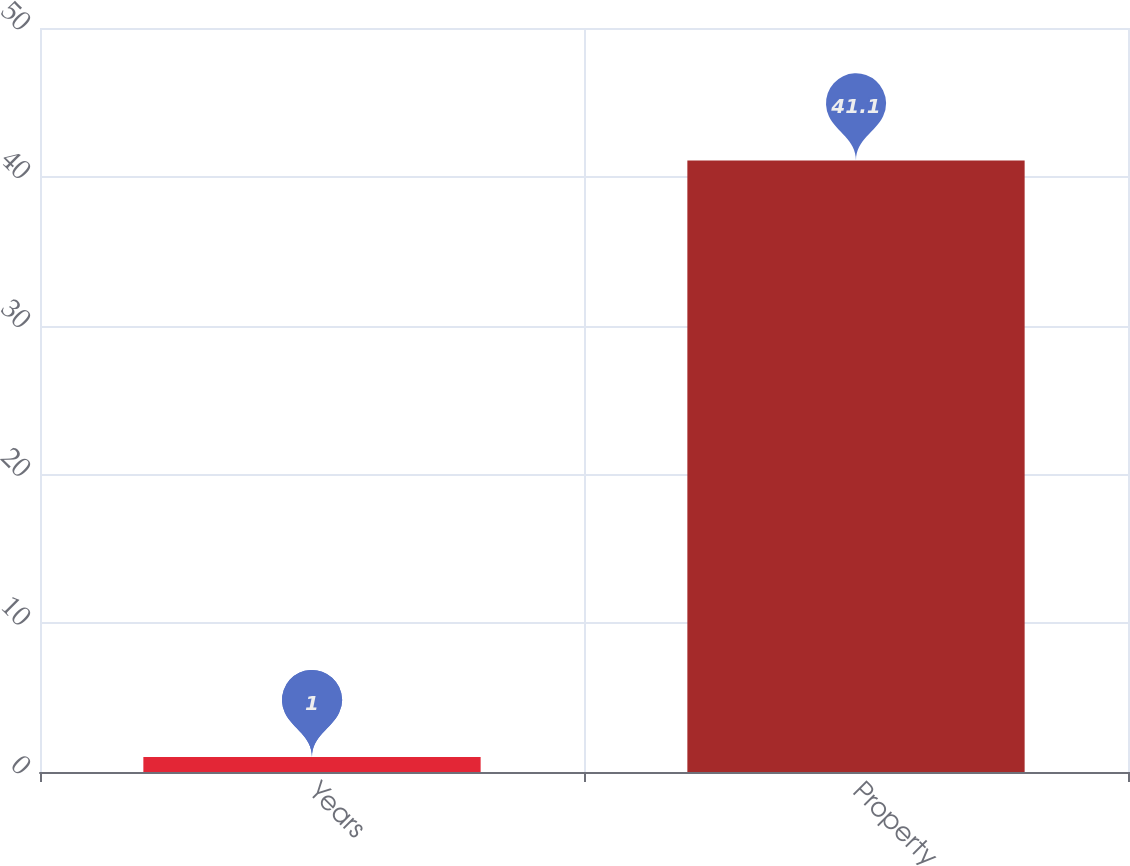Convert chart to OTSL. <chart><loc_0><loc_0><loc_500><loc_500><bar_chart><fcel>Years<fcel>Property<nl><fcel>1<fcel>41.1<nl></chart> 